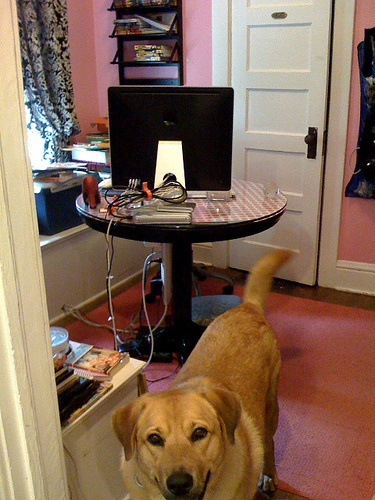Describe the objects in this image and their specific colors. I can see dining table in tan, black, darkgray, gray, and beige tones, dog in tan, olive, maroon, and gray tones, book in tan and brown tones, book in tan, white, lightblue, and gray tones, and book in tan, olive, and black tones in this image. 